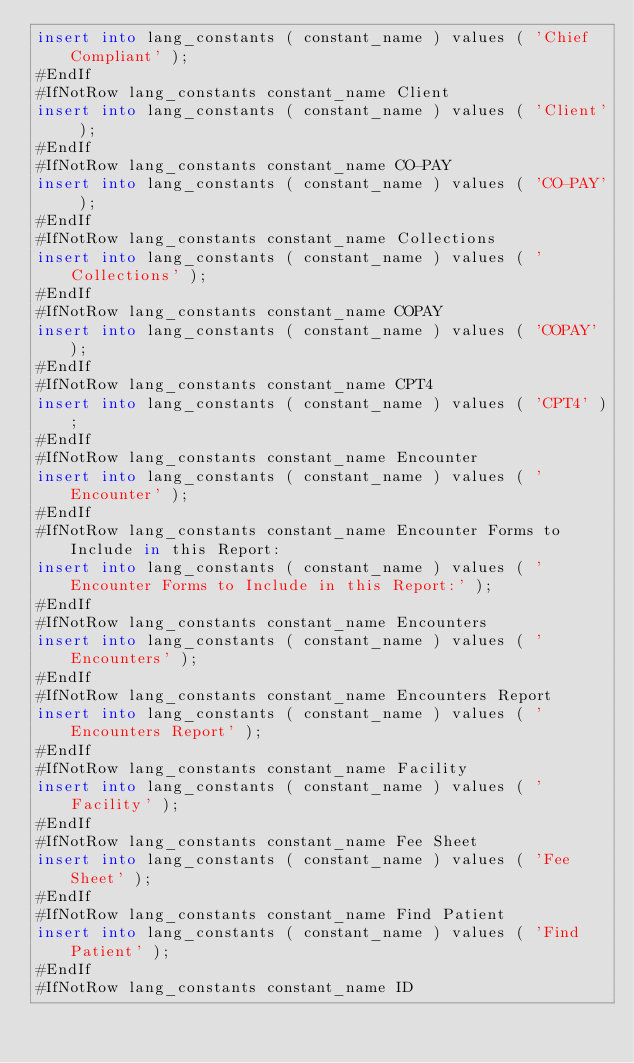<code> <loc_0><loc_0><loc_500><loc_500><_SQL_>insert into lang_constants ( constant_name ) values ( 'Chief Compliant' );
#EndIf
#IfNotRow lang_constants constant_name Client
insert into lang_constants ( constant_name ) values ( 'Client' );
#EndIf
#IfNotRow lang_constants constant_name CO-PAY
insert into lang_constants ( constant_name ) values ( 'CO-PAY' );
#EndIf
#IfNotRow lang_constants constant_name Collections
insert into lang_constants ( constant_name ) values ( 'Collections' );
#EndIf
#IfNotRow lang_constants constant_name COPAY
insert into lang_constants ( constant_name ) values ( 'COPAY' );
#EndIf
#IfNotRow lang_constants constant_name CPT4
insert into lang_constants ( constant_name ) values ( 'CPT4' );
#EndIf
#IfNotRow lang_constants constant_name Encounter
insert into lang_constants ( constant_name ) values ( 'Encounter' );
#EndIf
#IfNotRow lang_constants constant_name Encounter Forms to Include in this Report:
insert into lang_constants ( constant_name ) values ( 'Encounter Forms to Include in this Report:' );
#EndIf
#IfNotRow lang_constants constant_name Encounters
insert into lang_constants ( constant_name ) values ( 'Encounters' );
#EndIf
#IfNotRow lang_constants constant_name Encounters Report
insert into lang_constants ( constant_name ) values ( 'Encounters Report' );
#EndIf
#IfNotRow lang_constants constant_name Facility
insert into lang_constants ( constant_name ) values ( 'Facility' );
#EndIf
#IfNotRow lang_constants constant_name Fee Sheet
insert into lang_constants ( constant_name ) values ( 'Fee Sheet' );
#EndIf
#IfNotRow lang_constants constant_name Find Patient
insert into lang_constants ( constant_name ) values ( 'Find Patient' );
#EndIf
#IfNotRow lang_constants constant_name ID</code> 